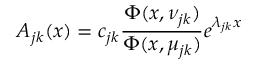<formula> <loc_0><loc_0><loc_500><loc_500>A _ { j k } ( x ) = c _ { j k } { \frac { \Phi ( x , \nu _ { j k } ) } { \Phi ( x , \mu _ { j k } ) } } e ^ { \lambda _ { j k } x }</formula> 